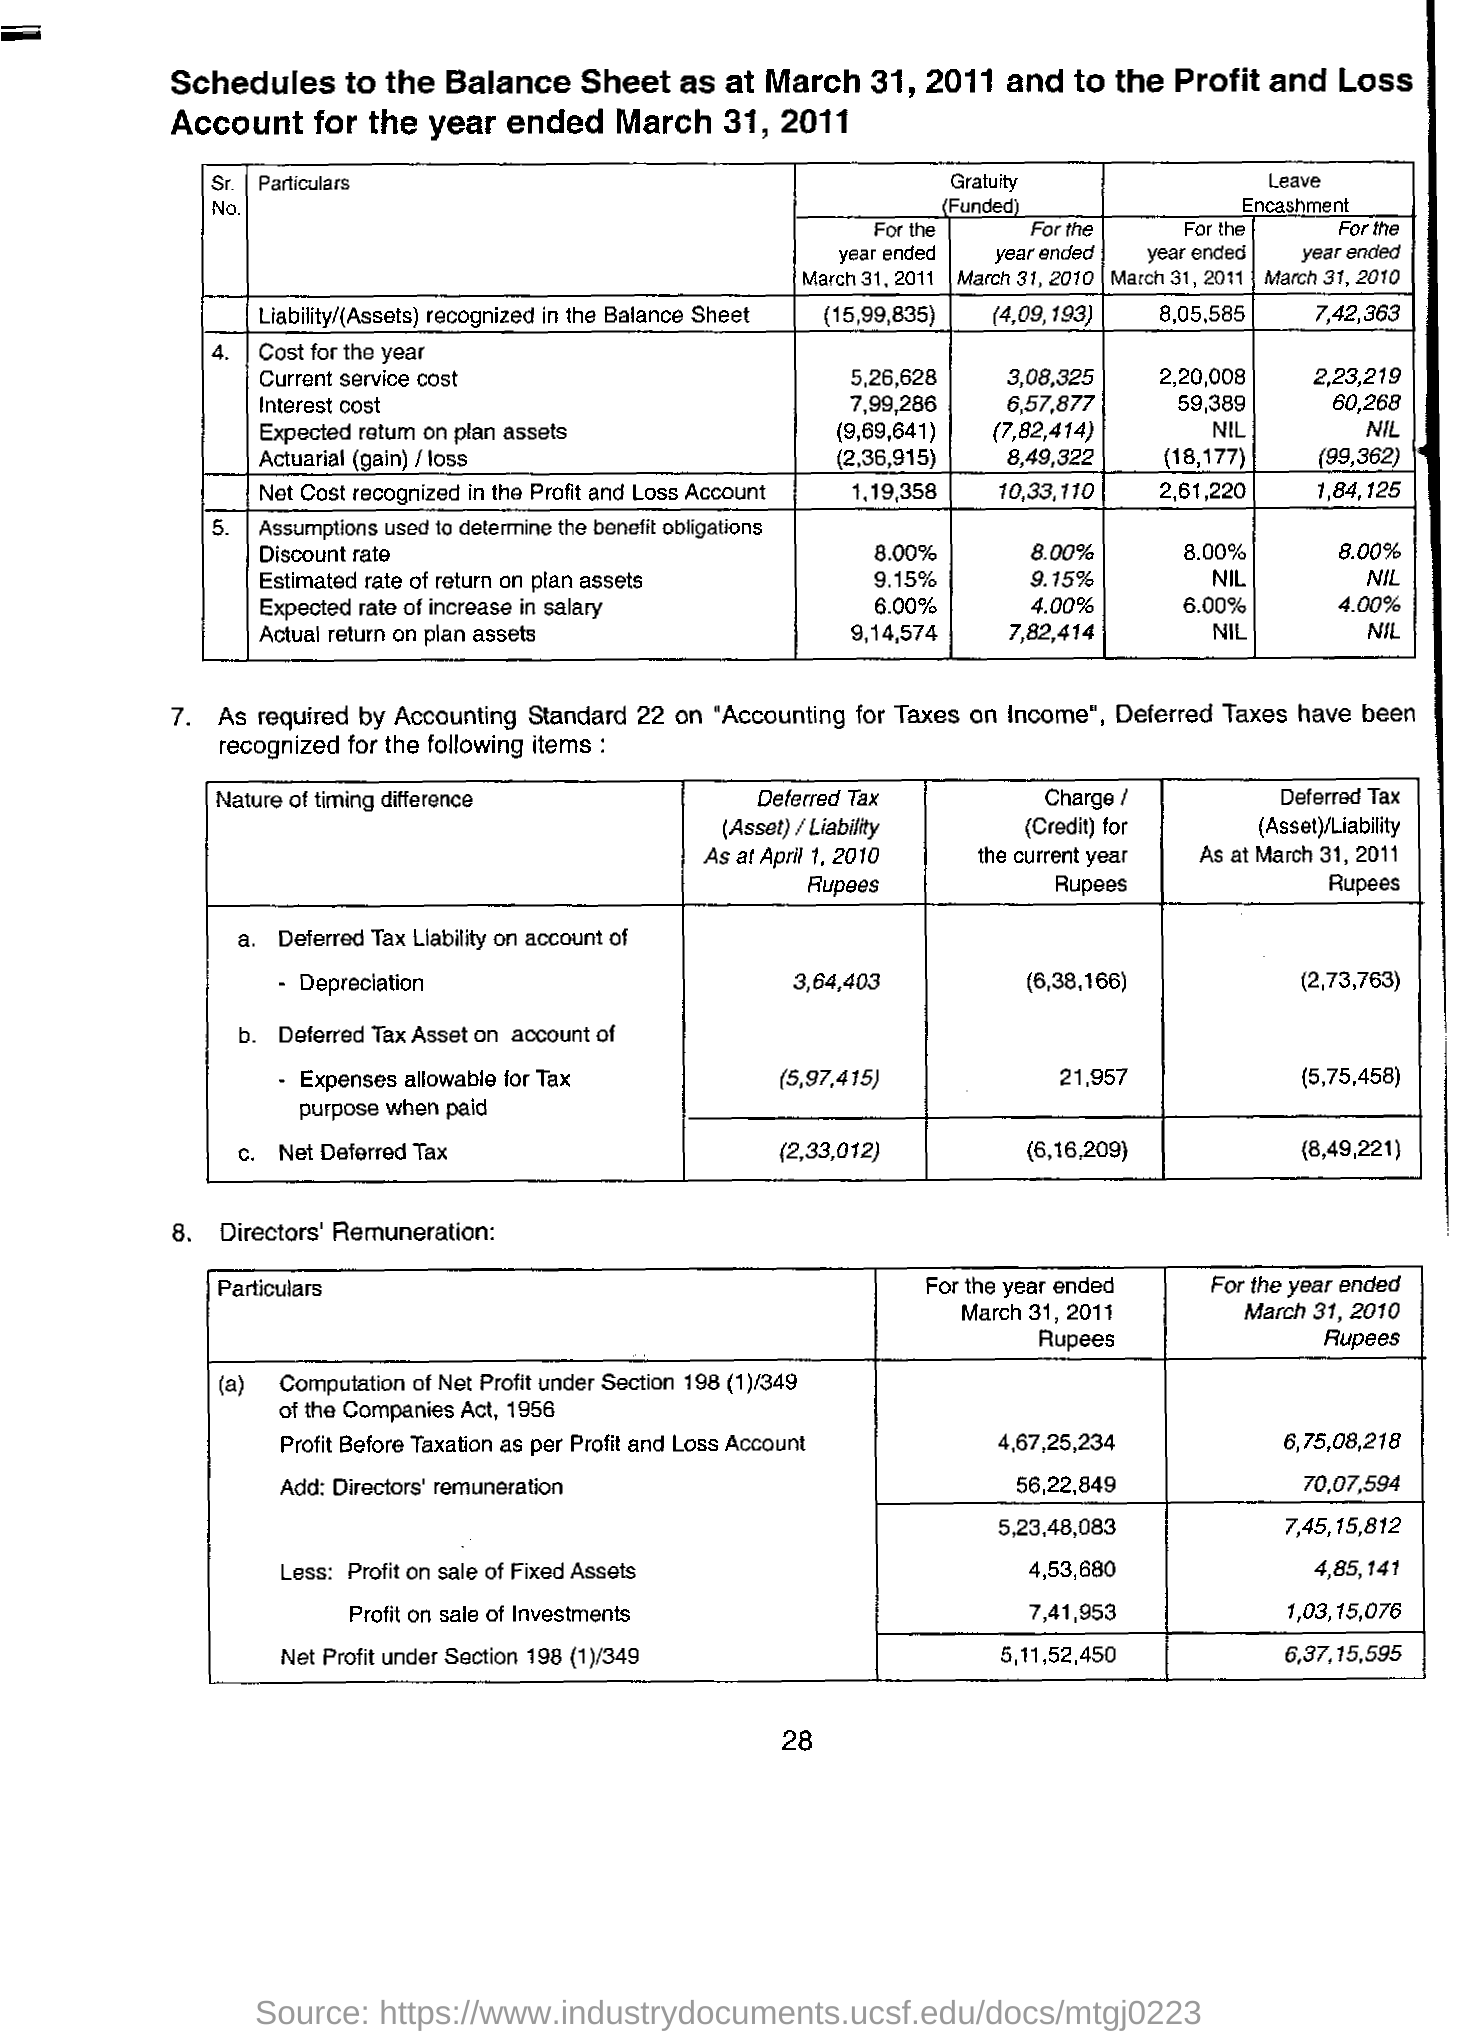What is Net Deffered as at April 2010?
Your answer should be very brief. 2,33,012. What is Net Deffered Tax liability on account of depreciation of as at April 2010?
Offer a very short reply. 364403. As per this page which date and year is scheduled for?
Give a very brief answer. March 31, 2011. 